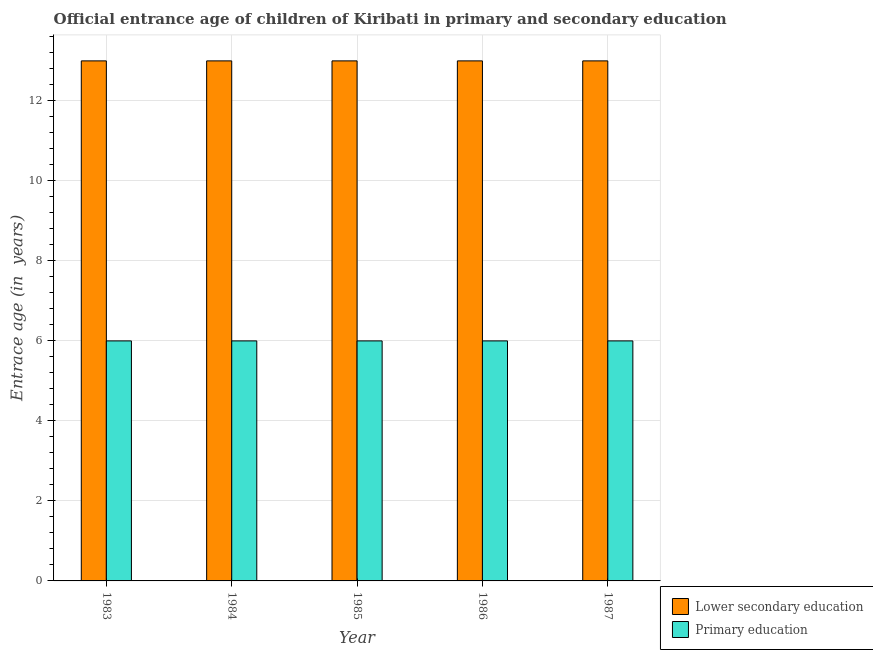How many groups of bars are there?
Offer a very short reply. 5. Are the number of bars per tick equal to the number of legend labels?
Your answer should be very brief. Yes. How many bars are there on the 2nd tick from the right?
Your answer should be compact. 2. What is the label of the 2nd group of bars from the left?
Provide a succinct answer. 1984. In how many cases, is the number of bars for a given year not equal to the number of legend labels?
Keep it short and to the point. 0. What is the entrance age of chiildren in primary education in 1983?
Keep it short and to the point. 6. Across all years, what is the maximum entrance age of children in lower secondary education?
Your response must be concise. 13. Across all years, what is the minimum entrance age of children in lower secondary education?
Provide a short and direct response. 13. What is the total entrance age of children in lower secondary education in the graph?
Your answer should be very brief. 65. What is the difference between the entrance age of chiildren in primary education in 1984 and the entrance age of children in lower secondary education in 1986?
Your answer should be compact. 0. What is the average entrance age of children in lower secondary education per year?
Your answer should be very brief. 13. In how many years, is the entrance age of chiildren in primary education greater than 9.6 years?
Your response must be concise. 0. What is the ratio of the entrance age of children in lower secondary education in 1986 to that in 1987?
Your answer should be very brief. 1. What does the 2nd bar from the left in 1986 represents?
Keep it short and to the point. Primary education. How many bars are there?
Ensure brevity in your answer.  10. Are all the bars in the graph horizontal?
Give a very brief answer. No. How many years are there in the graph?
Your answer should be very brief. 5. Where does the legend appear in the graph?
Provide a short and direct response. Bottom right. What is the title of the graph?
Keep it short and to the point. Official entrance age of children of Kiribati in primary and secondary education. What is the label or title of the Y-axis?
Ensure brevity in your answer.  Entrace age (in  years). What is the Entrace age (in  years) in Primary education in 1984?
Provide a succinct answer. 6. What is the Entrace age (in  years) of Primary education in 1985?
Your response must be concise. 6. What is the Entrace age (in  years) in Primary education in 1986?
Your response must be concise. 6. What is the Entrace age (in  years) of Lower secondary education in 1987?
Give a very brief answer. 13. What is the Entrace age (in  years) in Primary education in 1987?
Your response must be concise. 6. Across all years, what is the maximum Entrace age (in  years) in Lower secondary education?
Your answer should be very brief. 13. Across all years, what is the minimum Entrace age (in  years) in Lower secondary education?
Your response must be concise. 13. Across all years, what is the minimum Entrace age (in  years) in Primary education?
Your answer should be very brief. 6. What is the total Entrace age (in  years) of Lower secondary education in the graph?
Your answer should be very brief. 65. What is the total Entrace age (in  years) in Primary education in the graph?
Your answer should be very brief. 30. What is the difference between the Entrace age (in  years) in Primary education in 1983 and that in 1984?
Keep it short and to the point. 0. What is the difference between the Entrace age (in  years) of Lower secondary education in 1983 and that in 1986?
Your answer should be compact. 0. What is the difference between the Entrace age (in  years) of Primary education in 1983 and that in 1986?
Keep it short and to the point. 0. What is the difference between the Entrace age (in  years) in Lower secondary education in 1983 and that in 1987?
Provide a short and direct response. 0. What is the difference between the Entrace age (in  years) in Primary education in 1983 and that in 1987?
Keep it short and to the point. 0. What is the difference between the Entrace age (in  years) of Primary education in 1984 and that in 1985?
Make the answer very short. 0. What is the difference between the Entrace age (in  years) of Primary education in 1984 and that in 1986?
Your answer should be very brief. 0. What is the difference between the Entrace age (in  years) of Lower secondary education in 1986 and that in 1987?
Give a very brief answer. 0. What is the difference between the Entrace age (in  years) of Lower secondary education in 1983 and the Entrace age (in  years) of Primary education in 1984?
Provide a short and direct response. 7. What is the difference between the Entrace age (in  years) in Lower secondary education in 1983 and the Entrace age (in  years) in Primary education in 1986?
Offer a very short reply. 7. What is the difference between the Entrace age (in  years) of Lower secondary education in 1983 and the Entrace age (in  years) of Primary education in 1987?
Make the answer very short. 7. What is the difference between the Entrace age (in  years) of Lower secondary education in 1984 and the Entrace age (in  years) of Primary education in 1986?
Provide a short and direct response. 7. What is the difference between the Entrace age (in  years) in Lower secondary education in 1984 and the Entrace age (in  years) in Primary education in 1987?
Provide a short and direct response. 7. What is the difference between the Entrace age (in  years) of Lower secondary education in 1985 and the Entrace age (in  years) of Primary education in 1987?
Offer a very short reply. 7. What is the difference between the Entrace age (in  years) in Lower secondary education in 1986 and the Entrace age (in  years) in Primary education in 1987?
Offer a terse response. 7. What is the average Entrace age (in  years) of Primary education per year?
Provide a short and direct response. 6. In the year 1987, what is the difference between the Entrace age (in  years) of Lower secondary education and Entrace age (in  years) of Primary education?
Ensure brevity in your answer.  7. What is the ratio of the Entrace age (in  years) of Primary education in 1983 to that in 1984?
Provide a short and direct response. 1. What is the ratio of the Entrace age (in  years) of Lower secondary education in 1983 to that in 1985?
Offer a very short reply. 1. What is the ratio of the Entrace age (in  years) in Primary education in 1983 to that in 1985?
Your answer should be compact. 1. What is the ratio of the Entrace age (in  years) in Primary education in 1983 to that in 1987?
Give a very brief answer. 1. What is the ratio of the Entrace age (in  years) in Lower secondary education in 1984 to that in 1985?
Your answer should be compact. 1. What is the ratio of the Entrace age (in  years) in Primary education in 1984 to that in 1985?
Your answer should be very brief. 1. What is the ratio of the Entrace age (in  years) of Primary education in 1984 to that in 1986?
Offer a very short reply. 1. What is the ratio of the Entrace age (in  years) of Lower secondary education in 1985 to that in 1986?
Your answer should be compact. 1. What is the ratio of the Entrace age (in  years) in Primary education in 1985 to that in 1986?
Keep it short and to the point. 1. What is the ratio of the Entrace age (in  years) in Lower secondary education in 1985 to that in 1987?
Offer a terse response. 1. What is the difference between the highest and the second highest Entrace age (in  years) of Lower secondary education?
Offer a very short reply. 0. 